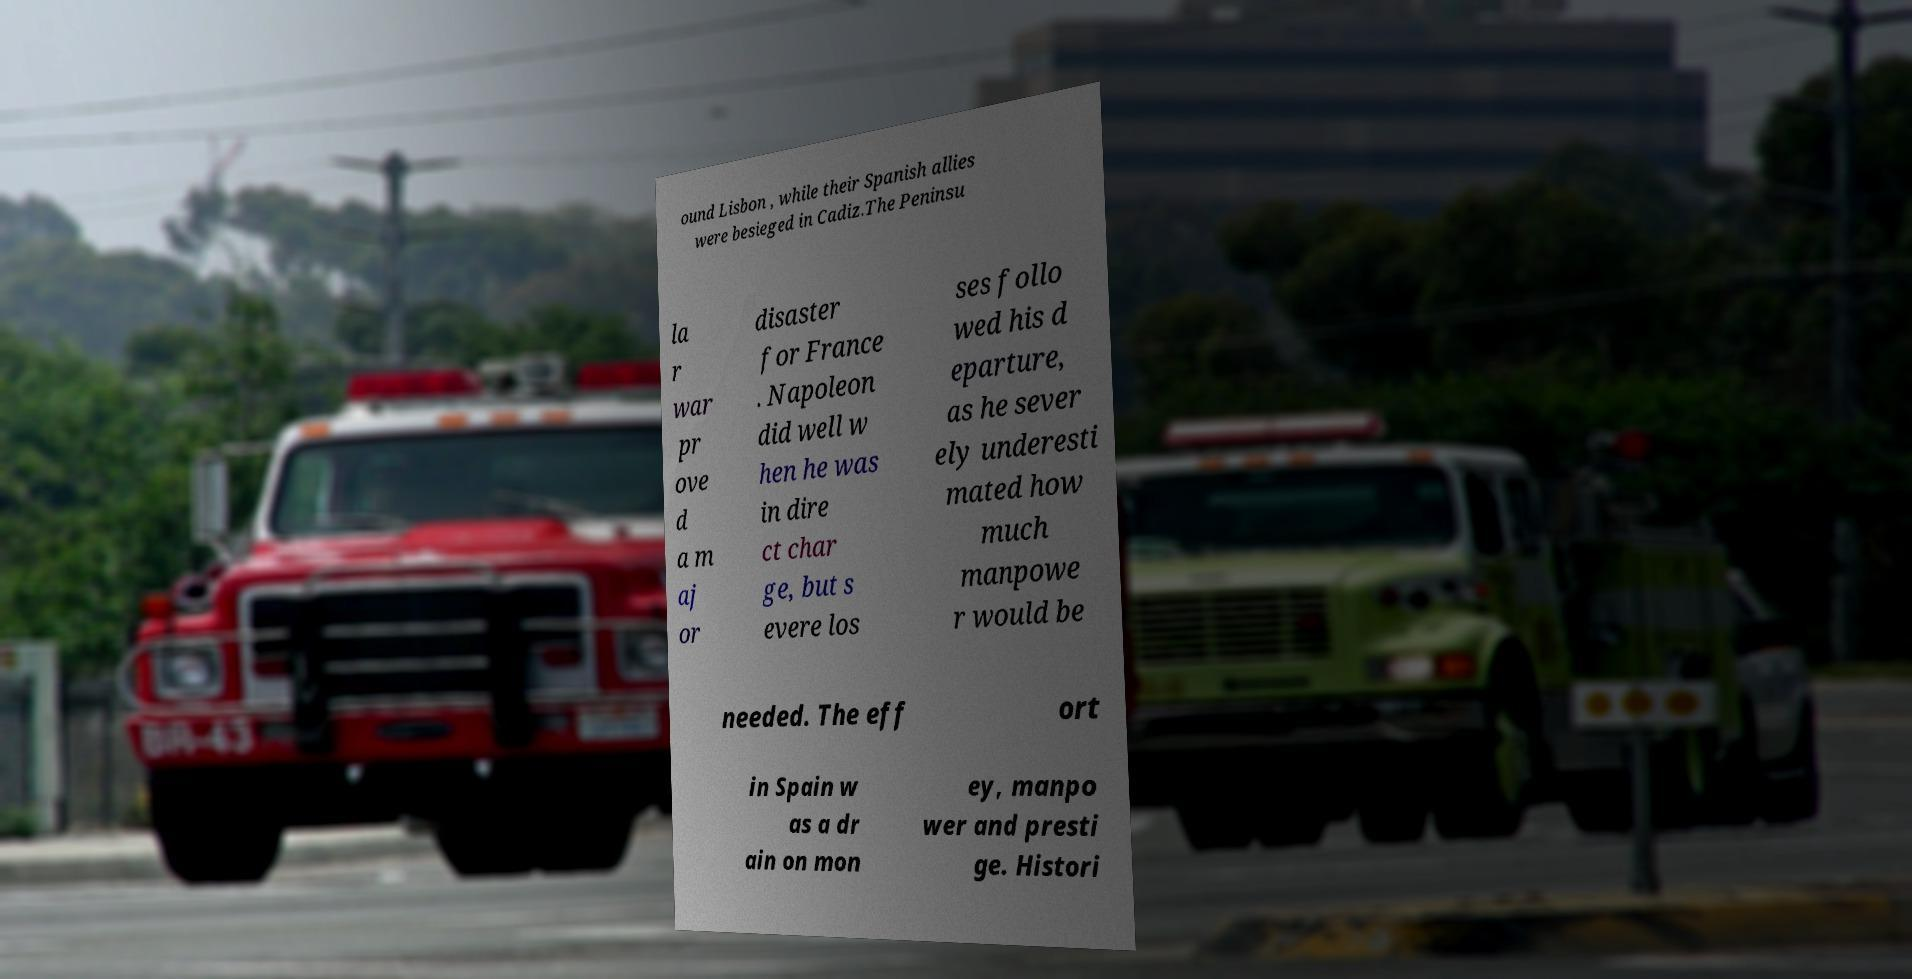Please read and relay the text visible in this image. What does it say? ound Lisbon , while their Spanish allies were besieged in Cadiz.The Peninsu la r war pr ove d a m aj or disaster for France . Napoleon did well w hen he was in dire ct char ge, but s evere los ses follo wed his d eparture, as he sever ely underesti mated how much manpowe r would be needed. The eff ort in Spain w as a dr ain on mon ey, manpo wer and presti ge. Histori 